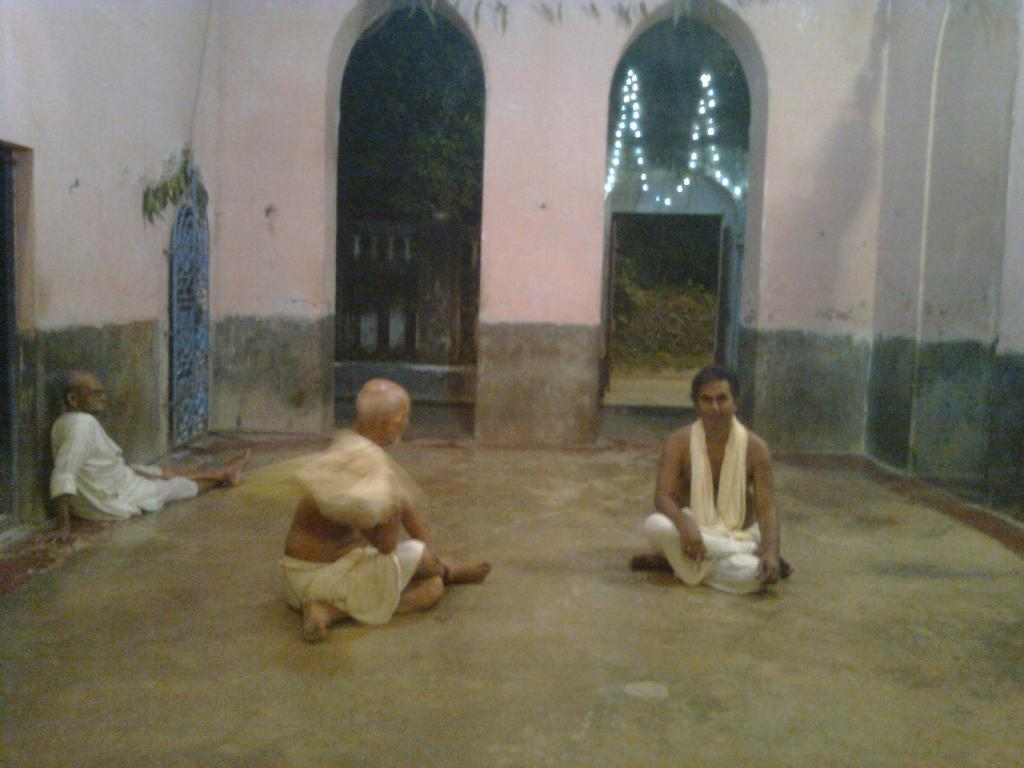What are the men in the image doing? The men in the image are sitting on the floor. What can be seen in the image that is used for cooking? There are grills in the image. What type of architectural feature is present in the image? There are gates in the image. What type of lighting is present in the image? Decor lights are present in the image. What type of vegetation is present in the image? There are trees and plants in the image. What type of destruction can be seen in the image? There is no destruction present in the image; it features men sitting on the floor, grills, gates, decor lights, trees, and plants. Is there any blood visible in the image? There is no blood present in the image. 